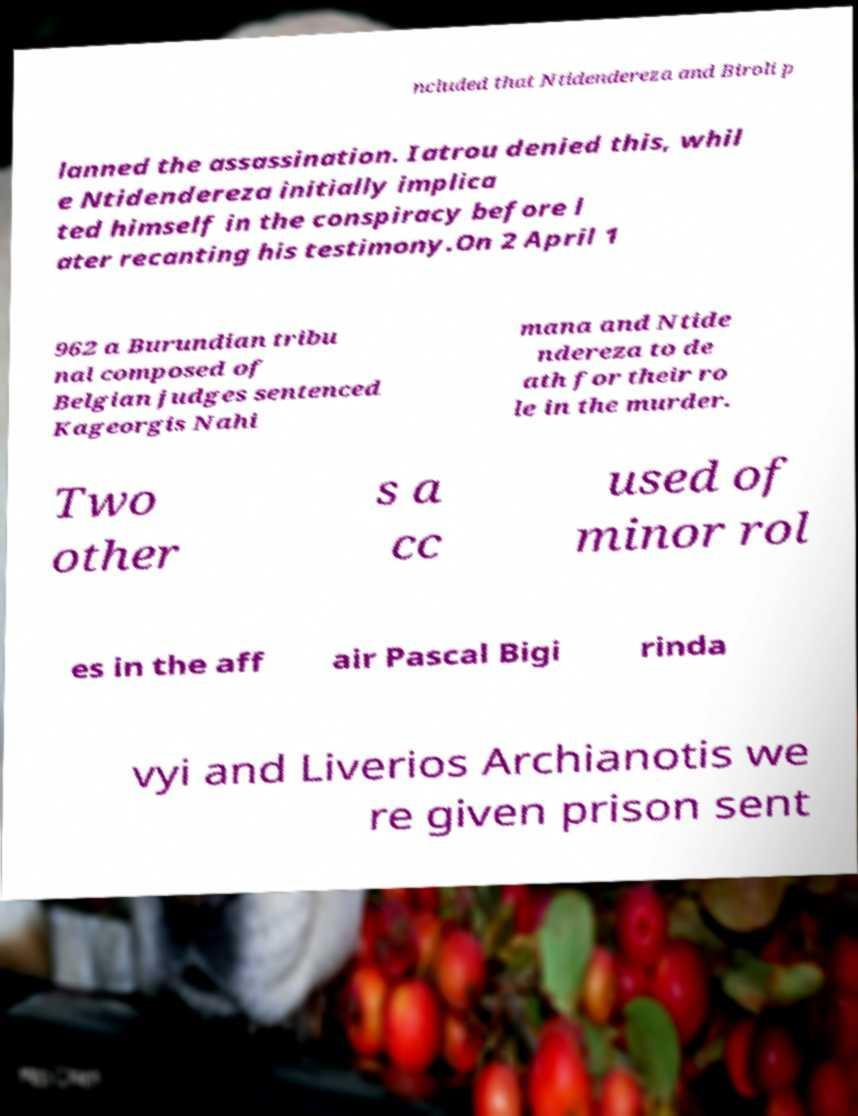I need the written content from this picture converted into text. Can you do that? ncluded that Ntidendereza and Biroli p lanned the assassination. Iatrou denied this, whil e Ntidendereza initially implica ted himself in the conspiracy before l ater recanting his testimony.On 2 April 1 962 a Burundian tribu nal composed of Belgian judges sentenced Kageorgis Nahi mana and Ntide ndereza to de ath for their ro le in the murder. Two other s a cc used of minor rol es in the aff air Pascal Bigi rinda vyi and Liverios Archianotis we re given prison sent 